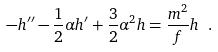Convert formula to latex. <formula><loc_0><loc_0><loc_500><loc_500>- h ^ { \prime \prime } - \frac { 1 } { 2 } \alpha h ^ { \prime } + \frac { 3 } { 2 } \alpha ^ { 2 } h = \frac { m ^ { 2 } } { f } h \ .</formula> 